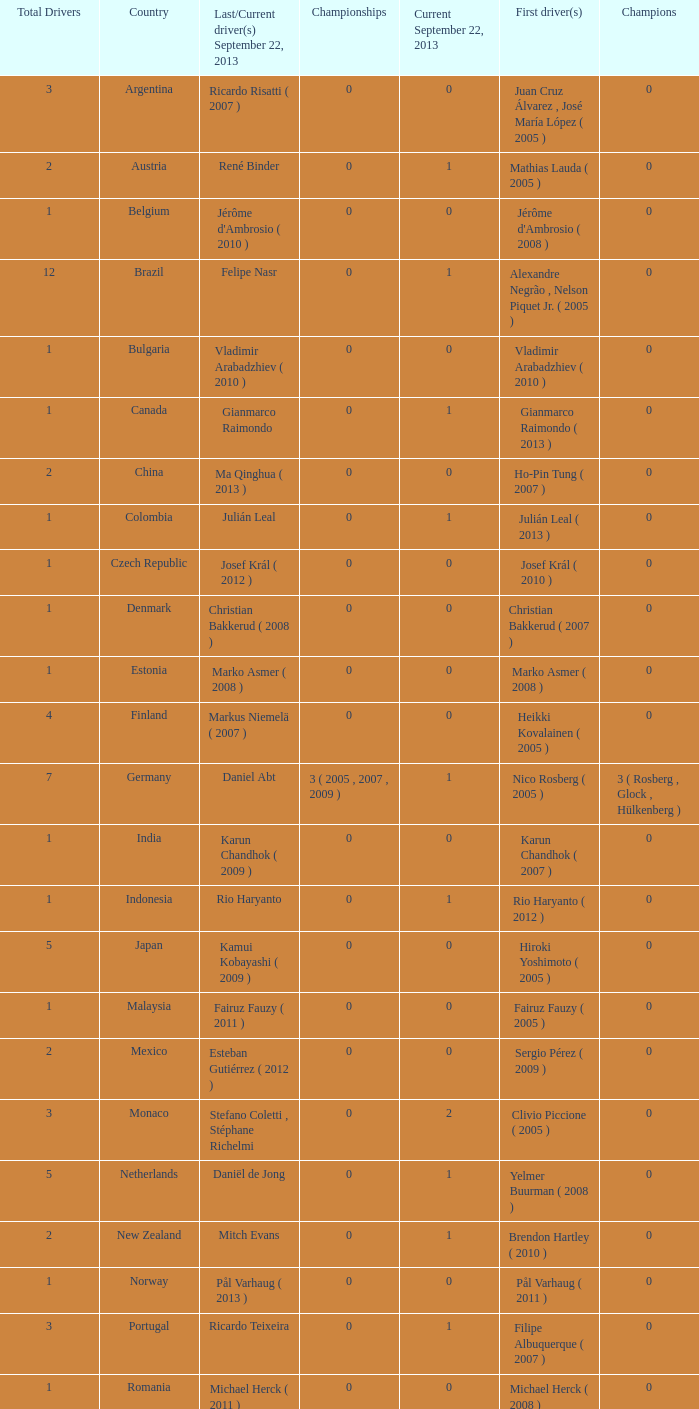How many entries are there for total drivers when the Last driver for september 22, 2013 was gianmarco raimondo? 1.0. 